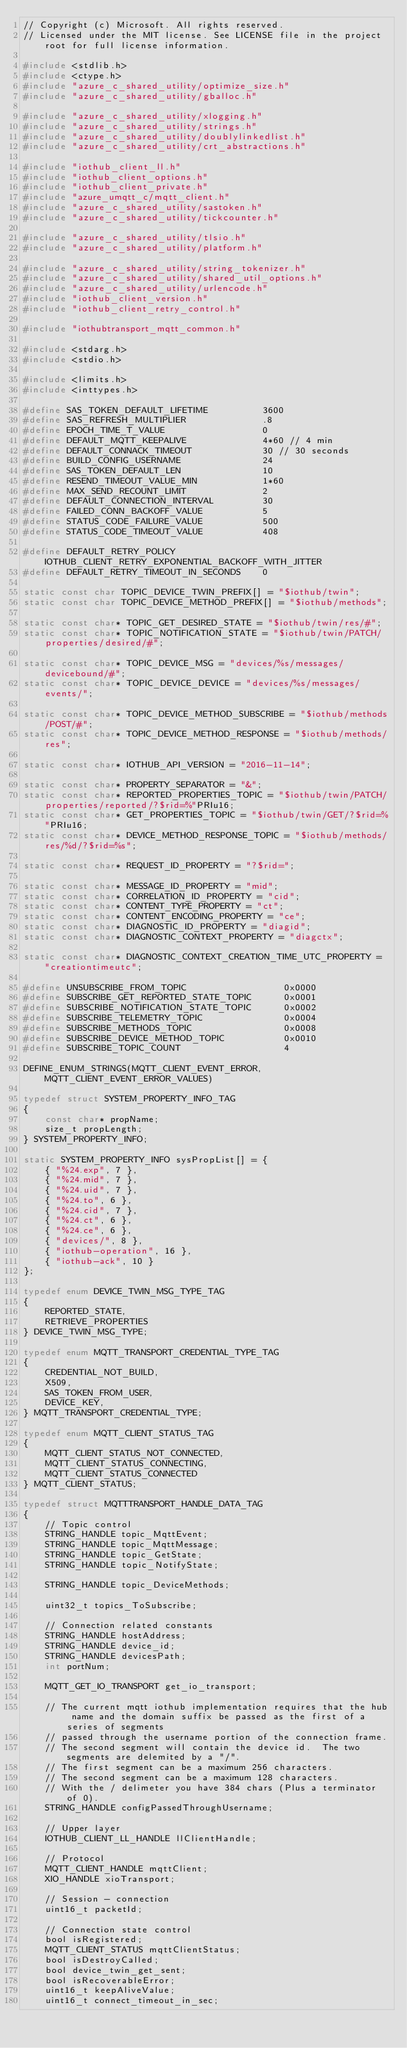<code> <loc_0><loc_0><loc_500><loc_500><_C_>// Copyright (c) Microsoft. All rights reserved.
// Licensed under the MIT license. See LICENSE file in the project root for full license information.

#include <stdlib.h>
#include <ctype.h>
#include "azure_c_shared_utility/optimize_size.h"
#include "azure_c_shared_utility/gballoc.h"

#include "azure_c_shared_utility/xlogging.h"
#include "azure_c_shared_utility/strings.h"
#include "azure_c_shared_utility/doublylinkedlist.h"
#include "azure_c_shared_utility/crt_abstractions.h"

#include "iothub_client_ll.h"
#include "iothub_client_options.h"
#include "iothub_client_private.h"
#include "azure_umqtt_c/mqtt_client.h"
#include "azure_c_shared_utility/sastoken.h"
#include "azure_c_shared_utility/tickcounter.h"

#include "azure_c_shared_utility/tlsio.h"
#include "azure_c_shared_utility/platform.h"

#include "azure_c_shared_utility/string_tokenizer.h"
#include "azure_c_shared_utility/shared_util_options.h"
#include "azure_c_shared_utility/urlencode.h"
#include "iothub_client_version.h"
#include "iothub_client_retry_control.h"

#include "iothubtransport_mqtt_common.h"

#include <stdarg.h>
#include <stdio.h>

#include <limits.h>
#include <inttypes.h>

#define SAS_TOKEN_DEFAULT_LIFETIME          3600
#define SAS_REFRESH_MULTIPLIER              .8
#define EPOCH_TIME_T_VALUE                  0
#define DEFAULT_MQTT_KEEPALIVE              4*60 // 4 min
#define DEFAULT_CONNACK_TIMEOUT             30 // 30 seconds
#define BUILD_CONFIG_USERNAME               24
#define SAS_TOKEN_DEFAULT_LEN               10
#define RESEND_TIMEOUT_VALUE_MIN            1*60
#define MAX_SEND_RECOUNT_LIMIT              2
#define DEFAULT_CONNECTION_INTERVAL         30
#define FAILED_CONN_BACKOFF_VALUE           5
#define STATUS_CODE_FAILURE_VALUE           500
#define STATUS_CODE_TIMEOUT_VALUE           408

#define DEFAULT_RETRY_POLICY                IOTHUB_CLIENT_RETRY_EXPONENTIAL_BACKOFF_WITH_JITTER
#define DEFAULT_RETRY_TIMEOUT_IN_SECONDS    0

static const char TOPIC_DEVICE_TWIN_PREFIX[] = "$iothub/twin";
static const char TOPIC_DEVICE_METHOD_PREFIX[] = "$iothub/methods";

static const char* TOPIC_GET_DESIRED_STATE = "$iothub/twin/res/#";
static const char* TOPIC_NOTIFICATION_STATE = "$iothub/twin/PATCH/properties/desired/#";

static const char* TOPIC_DEVICE_MSG = "devices/%s/messages/devicebound/#";
static const char* TOPIC_DEVICE_DEVICE = "devices/%s/messages/events/";

static const char* TOPIC_DEVICE_METHOD_SUBSCRIBE = "$iothub/methods/POST/#";
static const char* TOPIC_DEVICE_METHOD_RESPONSE = "$iothub/methods/res";

static const char* IOTHUB_API_VERSION = "2016-11-14";

static const char* PROPERTY_SEPARATOR = "&";
static const char* REPORTED_PROPERTIES_TOPIC = "$iothub/twin/PATCH/properties/reported/?$rid=%"PRIu16;
static const char* GET_PROPERTIES_TOPIC = "$iothub/twin/GET/?$rid=%"PRIu16;
static const char* DEVICE_METHOD_RESPONSE_TOPIC = "$iothub/methods/res/%d/?$rid=%s";

static const char* REQUEST_ID_PROPERTY = "?$rid=";

static const char* MESSAGE_ID_PROPERTY = "mid";
static const char* CORRELATION_ID_PROPERTY = "cid";
static const char* CONTENT_TYPE_PROPERTY = "ct";
static const char* CONTENT_ENCODING_PROPERTY = "ce";
static const char* DIAGNOSTIC_ID_PROPERTY = "diagid";
static const char* DIAGNOSTIC_CONTEXT_PROPERTY = "diagctx";

static const char* DIAGNOSTIC_CONTEXT_CREATION_TIME_UTC_PROPERTY = "creationtimeutc";

#define UNSUBSCRIBE_FROM_TOPIC                  0x0000
#define SUBSCRIBE_GET_REPORTED_STATE_TOPIC      0x0001
#define SUBSCRIBE_NOTIFICATION_STATE_TOPIC      0x0002
#define SUBSCRIBE_TELEMETRY_TOPIC               0x0004
#define SUBSCRIBE_METHODS_TOPIC                 0x0008
#define SUBSCRIBE_DEVICE_METHOD_TOPIC           0x0010
#define SUBSCRIBE_TOPIC_COUNT                   4

DEFINE_ENUM_STRINGS(MQTT_CLIENT_EVENT_ERROR, MQTT_CLIENT_EVENT_ERROR_VALUES)

typedef struct SYSTEM_PROPERTY_INFO_TAG
{
    const char* propName;
    size_t propLength;
} SYSTEM_PROPERTY_INFO;

static SYSTEM_PROPERTY_INFO sysPropList[] = {
    { "%24.exp", 7 },
    { "%24.mid", 7 },
    { "%24.uid", 7 },
    { "%24.to", 6 },
    { "%24.cid", 7 },
    { "%24.ct", 6 },
    { "%24.ce", 6 },
    { "devices/", 8 },
    { "iothub-operation", 16 },
    { "iothub-ack", 10 }
};

typedef enum DEVICE_TWIN_MSG_TYPE_TAG
{
    REPORTED_STATE,
    RETRIEVE_PROPERTIES
} DEVICE_TWIN_MSG_TYPE;

typedef enum MQTT_TRANSPORT_CREDENTIAL_TYPE_TAG
{
    CREDENTIAL_NOT_BUILD,
    X509,
    SAS_TOKEN_FROM_USER,
    DEVICE_KEY,
} MQTT_TRANSPORT_CREDENTIAL_TYPE;

typedef enum MQTT_CLIENT_STATUS_TAG
{
    MQTT_CLIENT_STATUS_NOT_CONNECTED,
    MQTT_CLIENT_STATUS_CONNECTING,
    MQTT_CLIENT_STATUS_CONNECTED
} MQTT_CLIENT_STATUS;

typedef struct MQTTTRANSPORT_HANDLE_DATA_TAG
{
    // Topic control
    STRING_HANDLE topic_MqttEvent;
    STRING_HANDLE topic_MqttMessage;
    STRING_HANDLE topic_GetState;
    STRING_HANDLE topic_NotifyState;

    STRING_HANDLE topic_DeviceMethods;

    uint32_t topics_ToSubscribe;

    // Connection related constants
    STRING_HANDLE hostAddress;
    STRING_HANDLE device_id;
    STRING_HANDLE devicesPath;
    int portNum;

    MQTT_GET_IO_TRANSPORT get_io_transport;

    // The current mqtt iothub implementation requires that the hub name and the domain suffix be passed as the first of a series of segments
    // passed through the username portion of the connection frame.
    // The second segment will contain the device id.  The two segments are delemited by a "/".
    // The first segment can be a maximum 256 characters.
    // The second segment can be a maximum 128 characters.
    // With the / delimeter you have 384 chars (Plus a terminator of 0).
    STRING_HANDLE configPassedThroughUsername;

    // Upper layer
    IOTHUB_CLIENT_LL_HANDLE llClientHandle;

    // Protocol 
    MQTT_CLIENT_HANDLE mqttClient;
    XIO_HANDLE xioTransport;

    // Session - connection
    uint16_t packetId;

    // Connection state control
    bool isRegistered;
    MQTT_CLIENT_STATUS mqttClientStatus;
    bool isDestroyCalled;
    bool device_twin_get_sent;
    bool isRecoverableError;
    uint16_t keepAliveValue;
    uint16_t connect_timeout_in_sec;</code> 